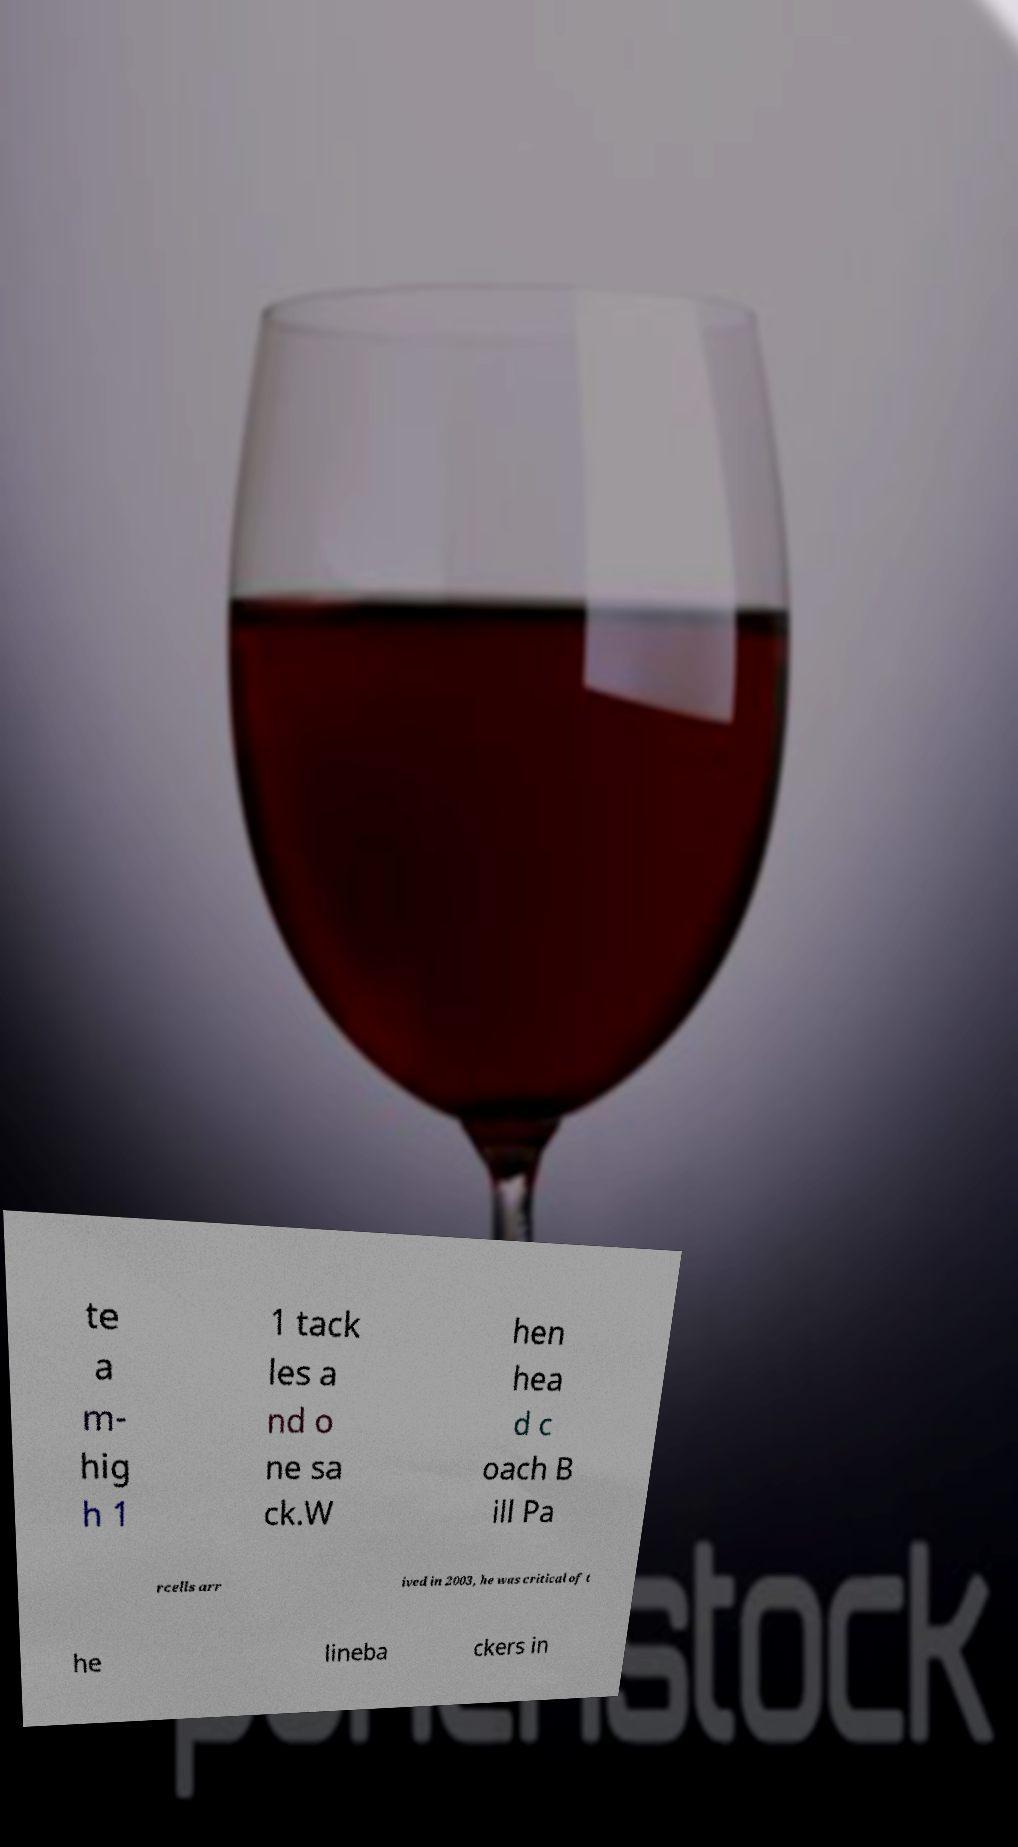For documentation purposes, I need the text within this image transcribed. Could you provide that? te a m- hig h 1 1 tack les a nd o ne sa ck.W hen hea d c oach B ill Pa rcells arr ived in 2003, he was critical of t he lineba ckers in 